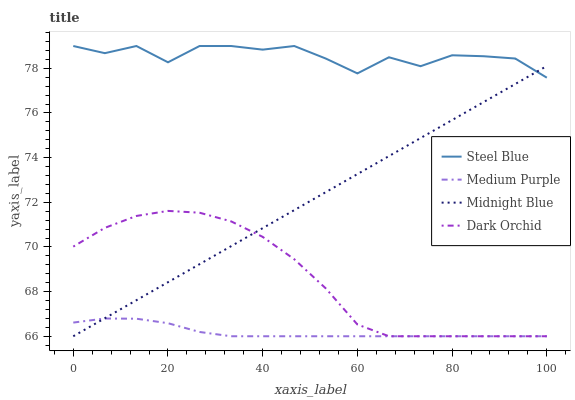Does Medium Purple have the minimum area under the curve?
Answer yes or no. Yes. Does Steel Blue have the maximum area under the curve?
Answer yes or no. Yes. Does Dark Orchid have the minimum area under the curve?
Answer yes or no. No. Does Dark Orchid have the maximum area under the curve?
Answer yes or no. No. Is Midnight Blue the smoothest?
Answer yes or no. Yes. Is Steel Blue the roughest?
Answer yes or no. Yes. Is Dark Orchid the smoothest?
Answer yes or no. No. Is Dark Orchid the roughest?
Answer yes or no. No. Does Medium Purple have the lowest value?
Answer yes or no. Yes. Does Steel Blue have the lowest value?
Answer yes or no. No. Does Steel Blue have the highest value?
Answer yes or no. Yes. Does Dark Orchid have the highest value?
Answer yes or no. No. Is Dark Orchid less than Steel Blue?
Answer yes or no. Yes. Is Steel Blue greater than Dark Orchid?
Answer yes or no. Yes. Does Dark Orchid intersect Medium Purple?
Answer yes or no. Yes. Is Dark Orchid less than Medium Purple?
Answer yes or no. No. Is Dark Orchid greater than Medium Purple?
Answer yes or no. No. Does Dark Orchid intersect Steel Blue?
Answer yes or no. No. 